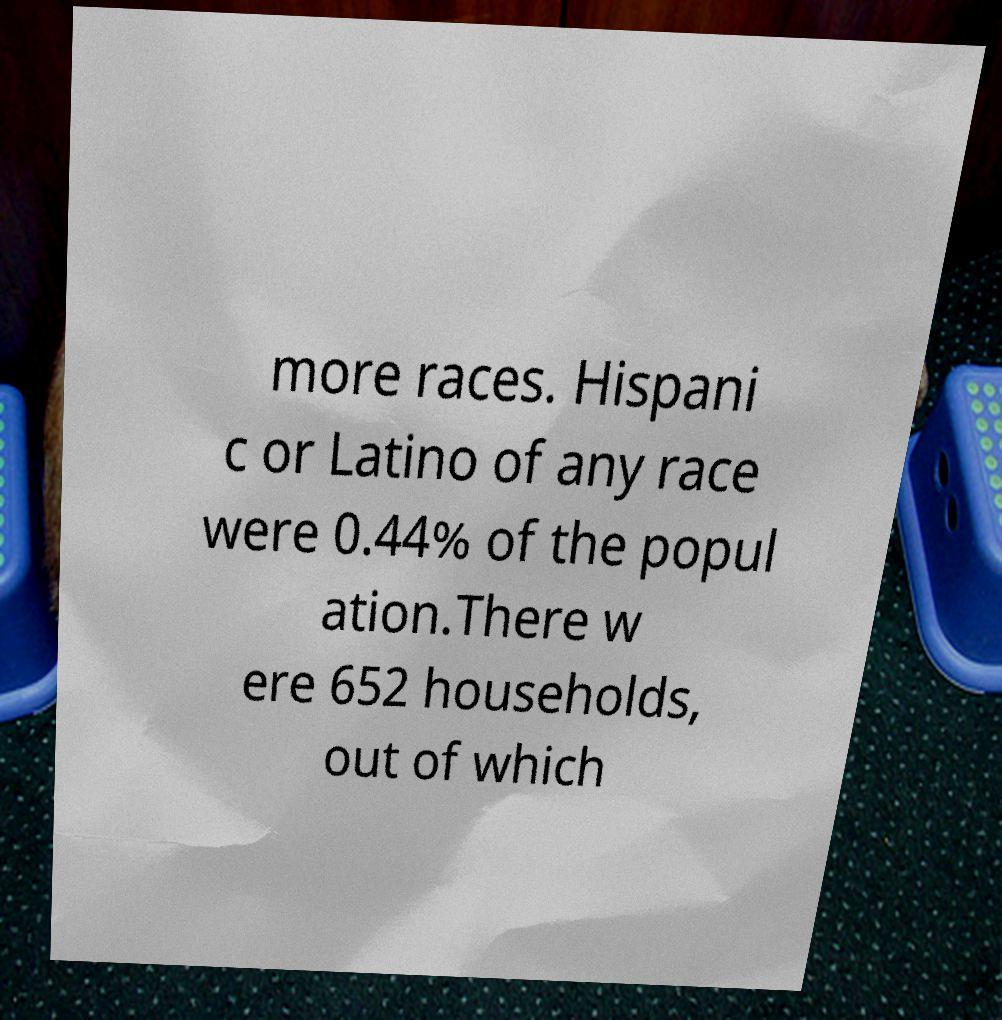What messages or text are displayed in this image? I need them in a readable, typed format. more races. Hispani c or Latino of any race were 0.44% of the popul ation.There w ere 652 households, out of which 